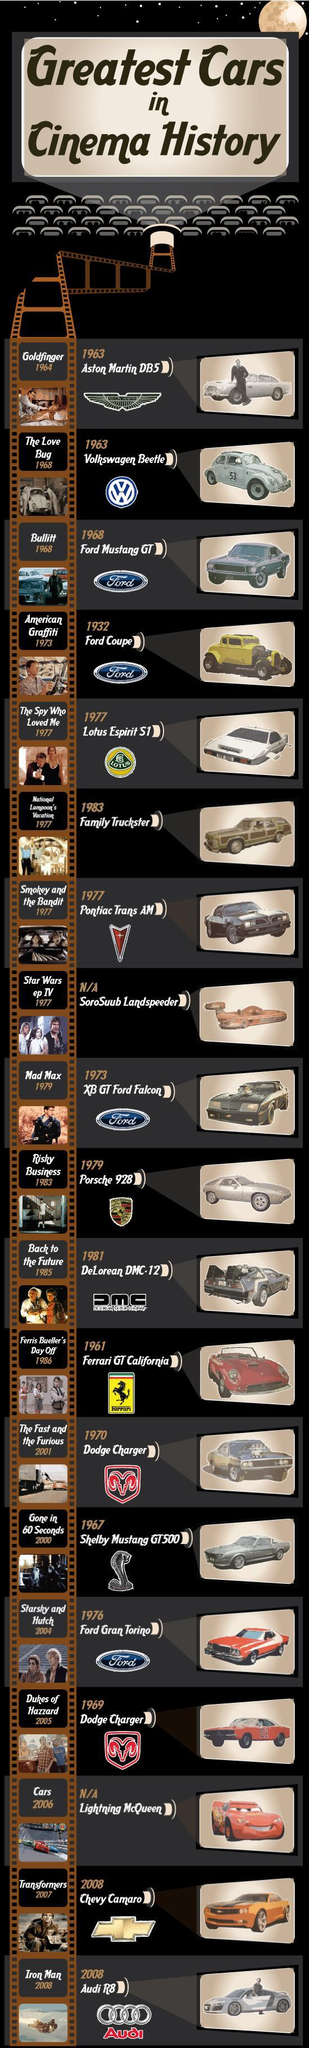What is the colour of the Ford Coupe, yellow or grey
Answer the question with a short phrase. yellow Dodge Charger was used in which movie Dukes of Hazzard 2005, The Fast and the Furious 2001 Audi R8 was used in which movie Iron Man 2008 What is the number written on the Volkswagen Beetle 53 WHat is written below the horse in the logo Ferrari 